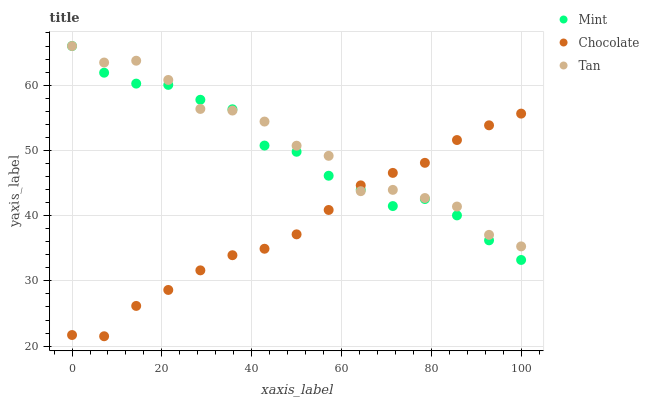Does Chocolate have the minimum area under the curve?
Answer yes or no. Yes. Does Tan have the maximum area under the curve?
Answer yes or no. Yes. Does Mint have the minimum area under the curve?
Answer yes or no. No. Does Mint have the maximum area under the curve?
Answer yes or no. No. Is Chocolate the smoothest?
Answer yes or no. Yes. Is Tan the roughest?
Answer yes or no. Yes. Is Mint the smoothest?
Answer yes or no. No. Is Mint the roughest?
Answer yes or no. No. Does Chocolate have the lowest value?
Answer yes or no. Yes. Does Mint have the lowest value?
Answer yes or no. No. Does Mint have the highest value?
Answer yes or no. Yes. Does Chocolate have the highest value?
Answer yes or no. No. Does Tan intersect Chocolate?
Answer yes or no. Yes. Is Tan less than Chocolate?
Answer yes or no. No. Is Tan greater than Chocolate?
Answer yes or no. No. 